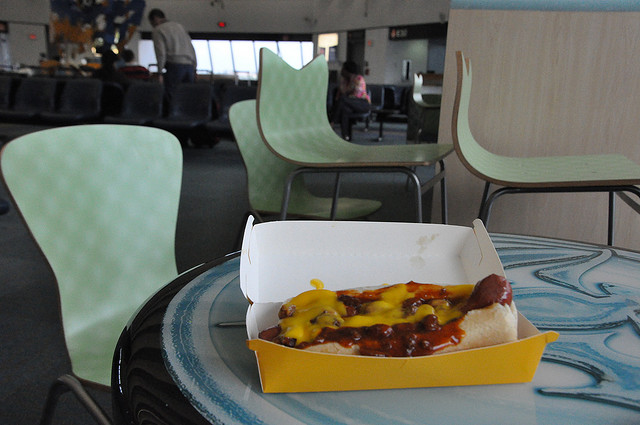<image>Where are the napkins? There are no napkins in the image. It could be in the kitchen. Where are the napkins? I don't know where the napkins are. They can be missing or not on the table. 